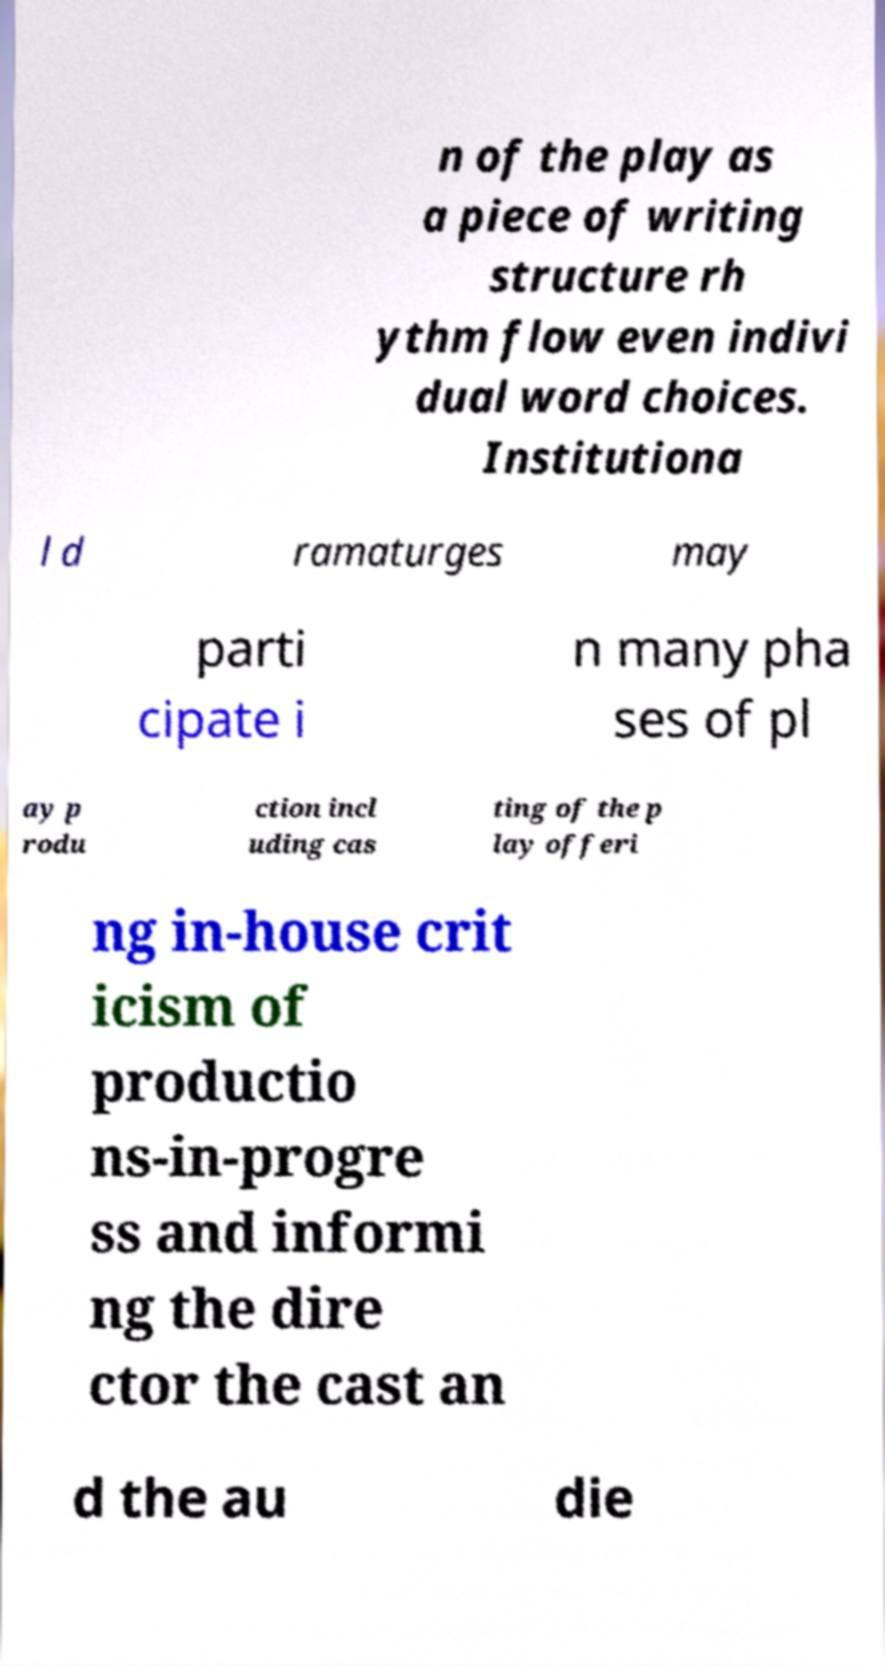Please identify and transcribe the text found in this image. n of the play as a piece of writing structure rh ythm flow even indivi dual word choices. Institutiona l d ramaturges may parti cipate i n many pha ses of pl ay p rodu ction incl uding cas ting of the p lay offeri ng in-house crit icism of productio ns-in-progre ss and informi ng the dire ctor the cast an d the au die 